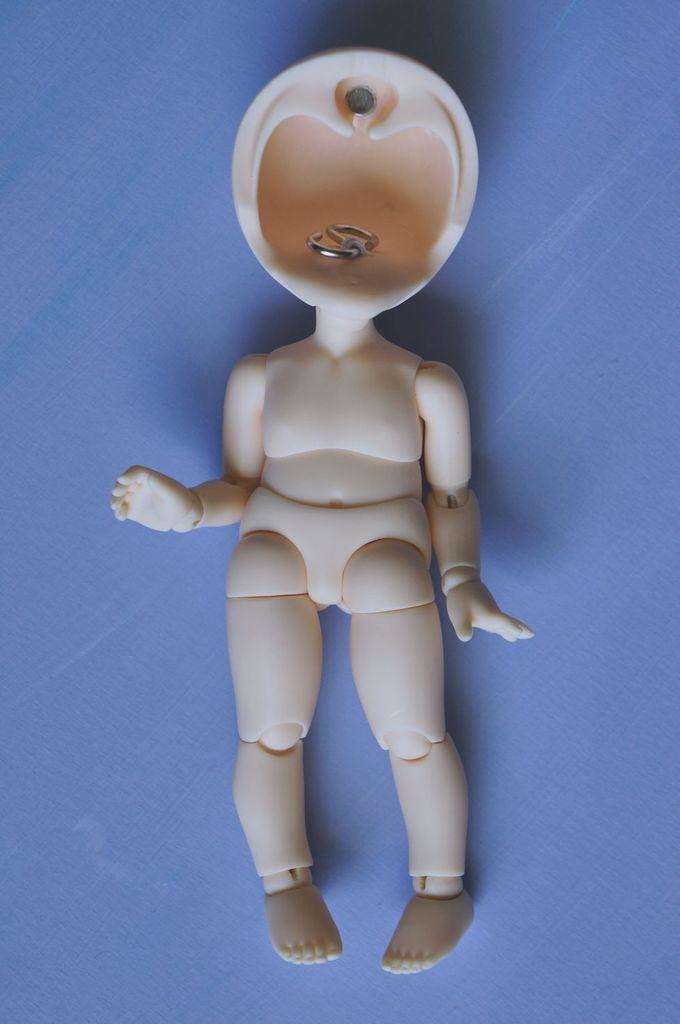Can you describe this image briefly? This is a zoomed in picture. In the center we can see the toy of a person which is lying on a blue color object seems to be the table. 